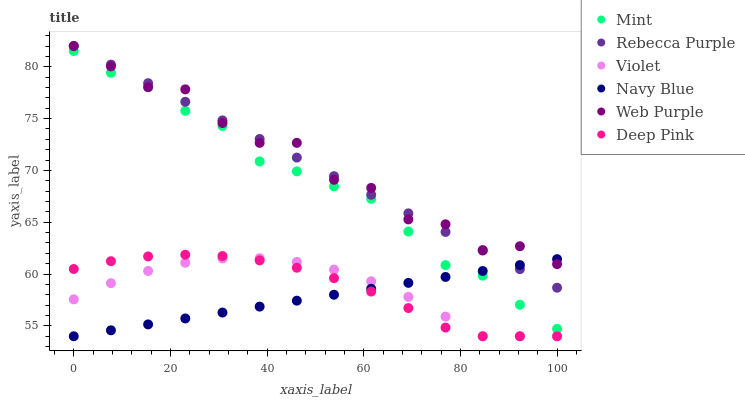Does Navy Blue have the minimum area under the curve?
Answer yes or no. Yes. Does Web Purple have the maximum area under the curve?
Answer yes or no. Yes. Does Web Purple have the minimum area under the curve?
Answer yes or no. No. Does Navy Blue have the maximum area under the curve?
Answer yes or no. No. Is Navy Blue the smoothest?
Answer yes or no. Yes. Is Web Purple the roughest?
Answer yes or no. Yes. Is Web Purple the smoothest?
Answer yes or no. No. Is Navy Blue the roughest?
Answer yes or no. No. Does Deep Pink have the lowest value?
Answer yes or no. Yes. Does Web Purple have the lowest value?
Answer yes or no. No. Does Rebecca Purple have the highest value?
Answer yes or no. Yes. Does Navy Blue have the highest value?
Answer yes or no. No. Is Deep Pink less than Rebecca Purple?
Answer yes or no. Yes. Is Rebecca Purple greater than Deep Pink?
Answer yes or no. Yes. Does Navy Blue intersect Mint?
Answer yes or no. Yes. Is Navy Blue less than Mint?
Answer yes or no. No. Is Navy Blue greater than Mint?
Answer yes or no. No. Does Deep Pink intersect Rebecca Purple?
Answer yes or no. No. 